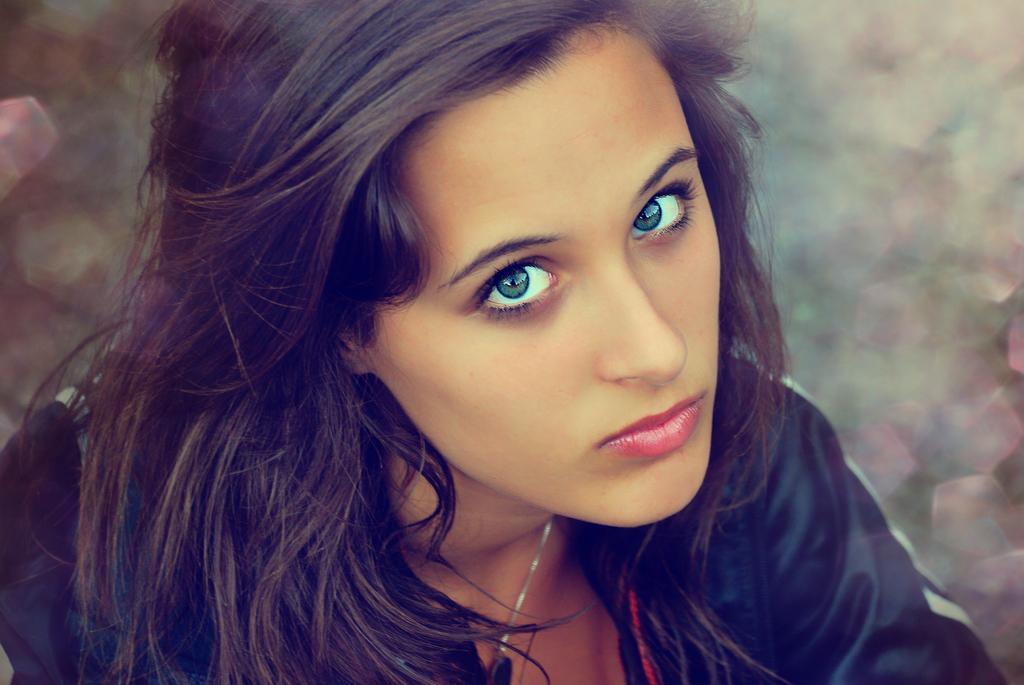Please provide a concise description of this image. In this image in the front there is a woman and the background is blurry. 